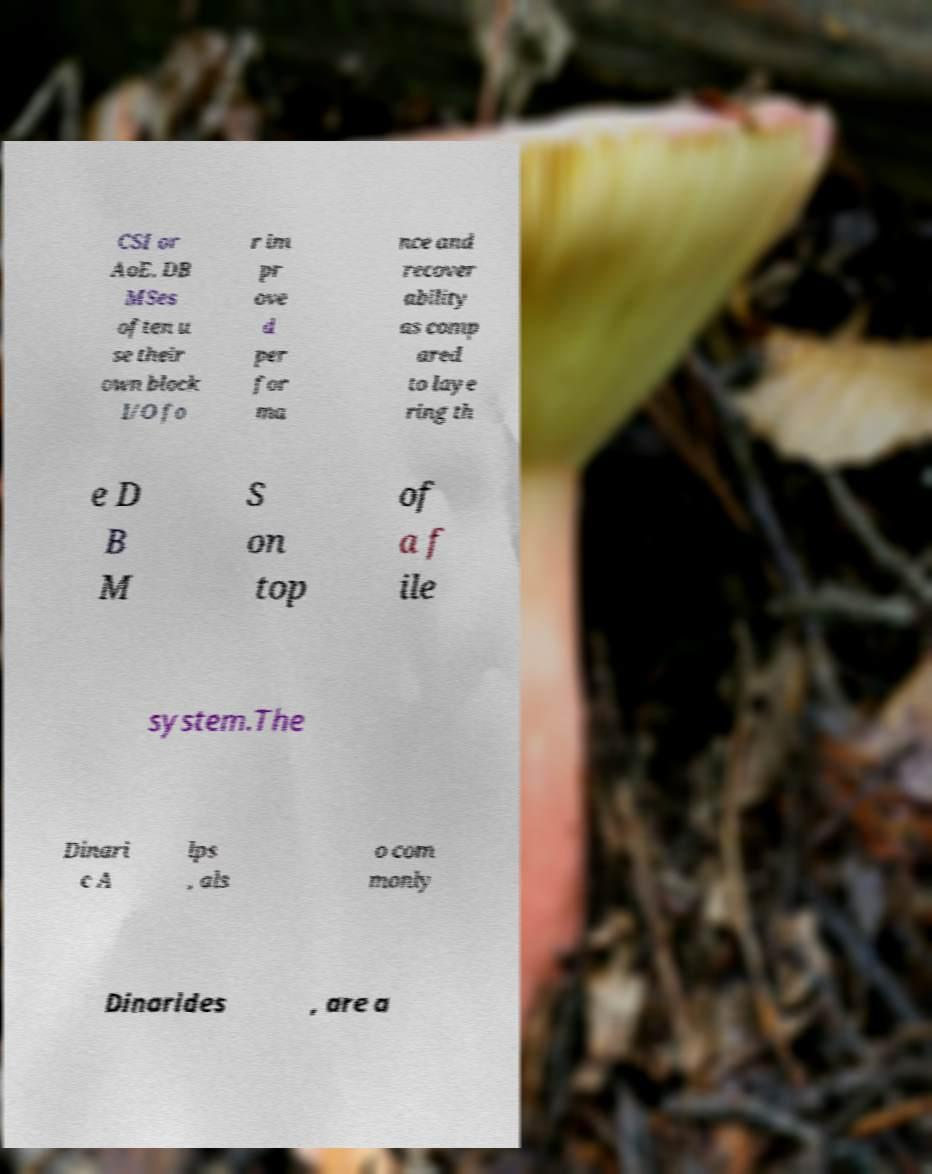Please read and relay the text visible in this image. What does it say? CSI or AoE. DB MSes often u se their own block I/O fo r im pr ove d per for ma nce and recover ability as comp ared to laye ring th e D B M S on top of a f ile system.The Dinari c A lps , als o com monly Dinarides , are a 